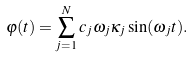Convert formula to latex. <formula><loc_0><loc_0><loc_500><loc_500>\varphi ( t ) = \sum _ { j = 1 } ^ { N } c _ { j } \omega _ { j } \kappa _ { j } \sin ( \omega _ { j } t ) .</formula> 